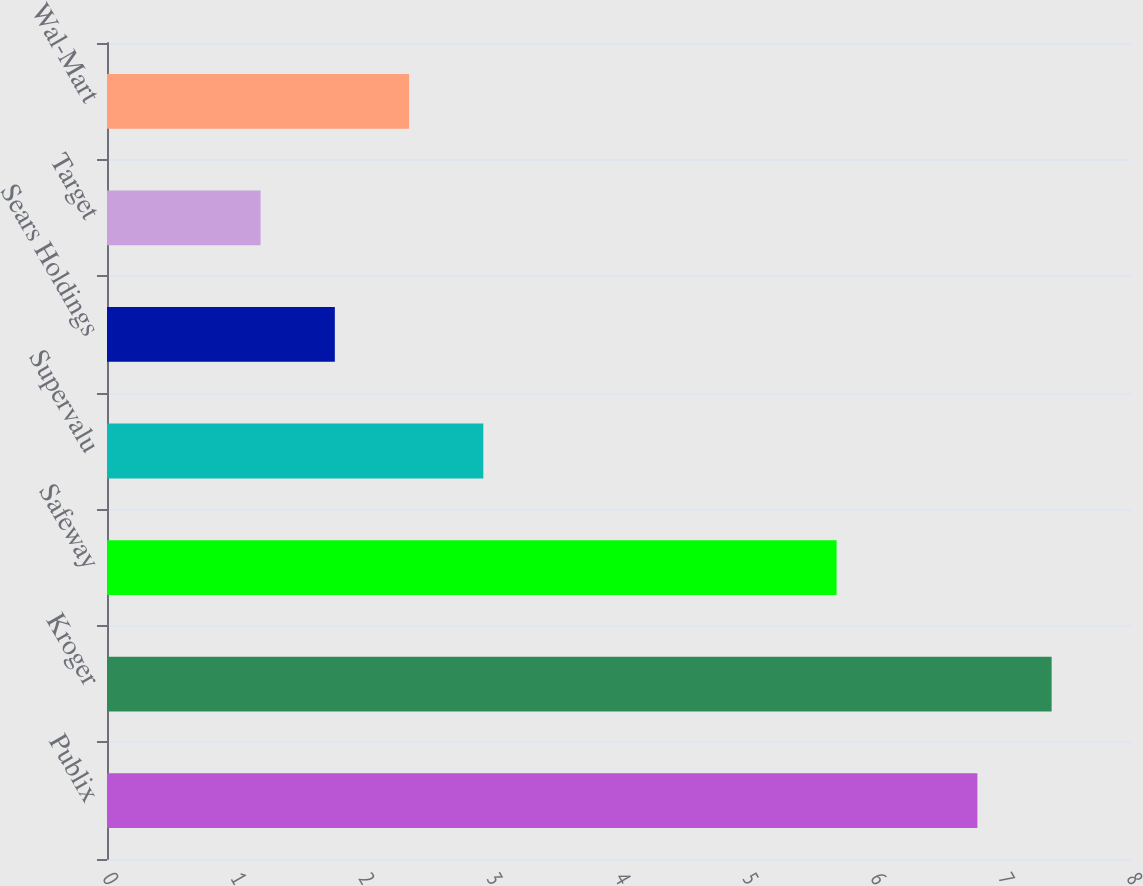Convert chart. <chart><loc_0><loc_0><loc_500><loc_500><bar_chart><fcel>Publix<fcel>Kroger<fcel>Safeway<fcel>Supervalu<fcel>Sears Holdings<fcel>Target<fcel>Wal-Mart<nl><fcel>6.8<fcel>7.38<fcel>5.7<fcel>2.94<fcel>1.78<fcel>1.2<fcel>2.36<nl></chart> 